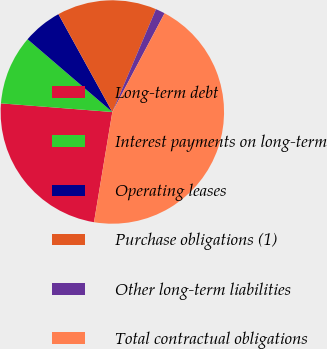Convert chart to OTSL. <chart><loc_0><loc_0><loc_500><loc_500><pie_chart><fcel>Long-term debt<fcel>Interest payments on long-term<fcel>Operating leases<fcel>Purchase obligations (1)<fcel>Other long-term liabilities<fcel>Total contractual obligations<nl><fcel>23.61%<fcel>10.05%<fcel>5.7%<fcel>14.41%<fcel>1.35%<fcel>44.88%<nl></chart> 